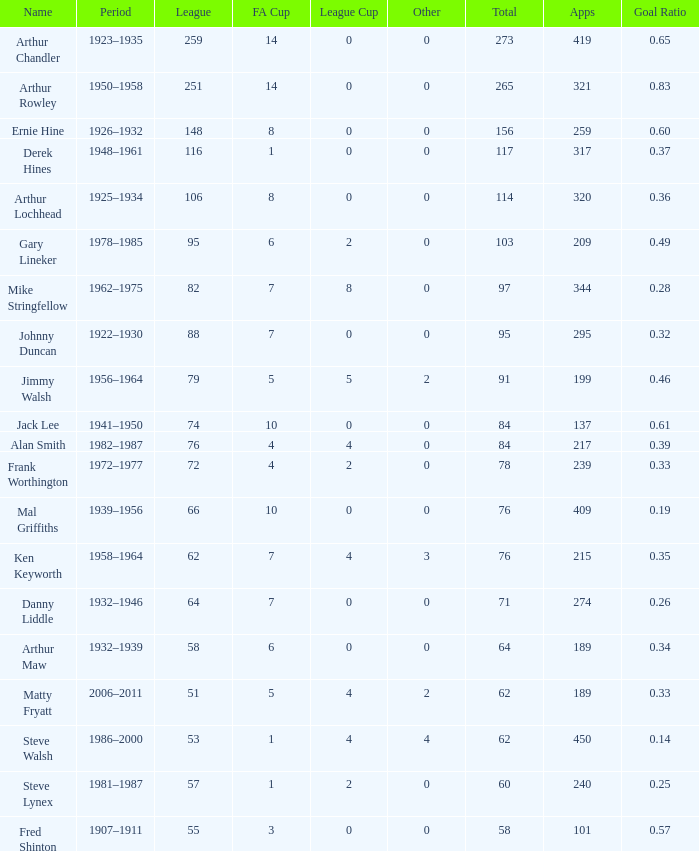What's the Highest Goal Ratio with a League of 88 and an FA Cup less than 7? None. 